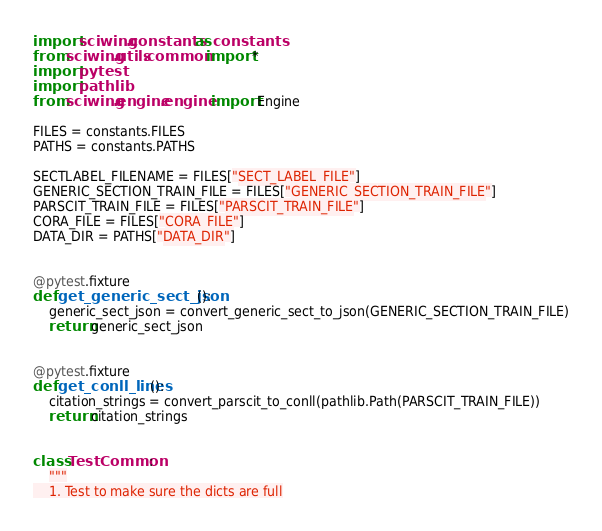Convert code to text. <code><loc_0><loc_0><loc_500><loc_500><_Python_>import sciwing.constants as constants
from sciwing.utils.common import *
import pytest
import pathlib
from sciwing.engine.engine import Engine

FILES = constants.FILES
PATHS = constants.PATHS

SECTLABEL_FILENAME = FILES["SECT_LABEL_FILE"]
GENERIC_SECTION_TRAIN_FILE = FILES["GENERIC_SECTION_TRAIN_FILE"]
PARSCIT_TRAIN_FILE = FILES["PARSCIT_TRAIN_FILE"]
CORA_FILE = FILES["CORA_FILE"]
DATA_DIR = PATHS["DATA_DIR"]


@pytest.fixture
def get_generic_sect_json():
    generic_sect_json = convert_generic_sect_to_json(GENERIC_SECTION_TRAIN_FILE)
    return generic_sect_json


@pytest.fixture
def get_conll_lines():
    citation_strings = convert_parscit_to_conll(pathlib.Path(PARSCIT_TRAIN_FILE))
    return citation_strings


class TestCommon:
    """
    1. Test to make sure the dicts are full</code> 